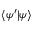<formula> <loc_0><loc_0><loc_500><loc_500>\langle \psi ^ { \prime } | \psi \rangle</formula> 